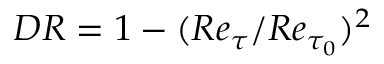<formula> <loc_0><loc_0><loc_500><loc_500>{ D R } = 1 - ( R e _ { \tau } / R e _ { \tau _ { 0 } } ) ^ { 2 }</formula> 